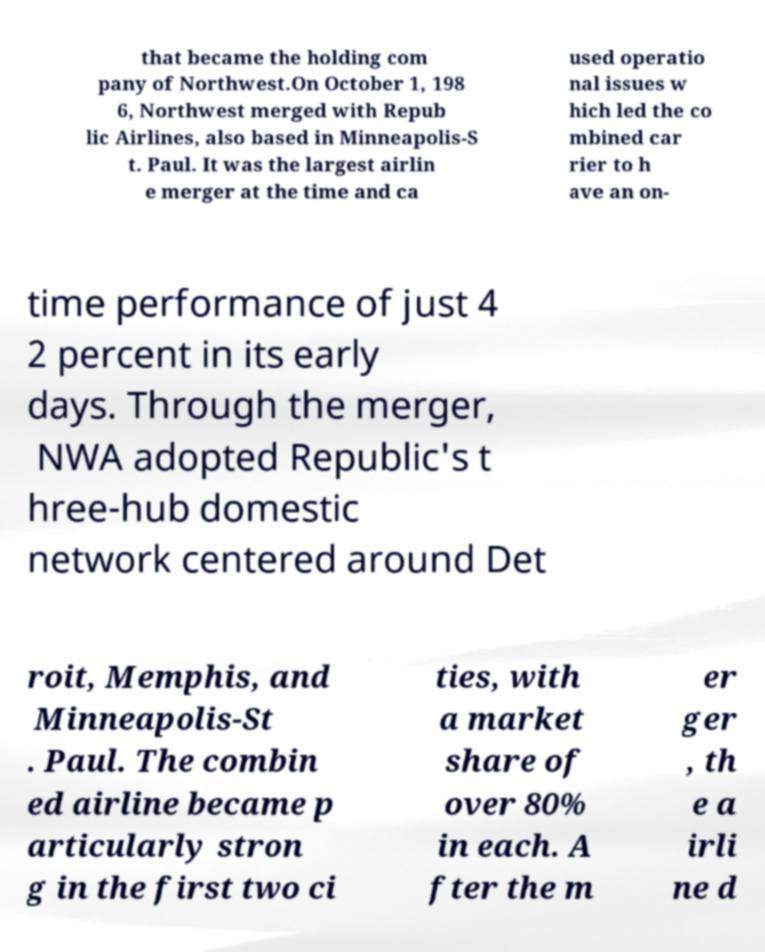Please identify and transcribe the text found in this image. that became the holding com pany of Northwest.On October 1, 198 6, Northwest merged with Repub lic Airlines, also based in Minneapolis-S t. Paul. It was the largest airlin e merger at the time and ca used operatio nal issues w hich led the co mbined car rier to h ave an on- time performance of just 4 2 percent in its early days. Through the merger, NWA adopted Republic's t hree-hub domestic network centered around Det roit, Memphis, and Minneapolis-St . Paul. The combin ed airline became p articularly stron g in the first two ci ties, with a market share of over 80% in each. A fter the m er ger , th e a irli ne d 